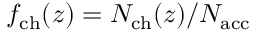<formula> <loc_0><loc_0><loc_500><loc_500>f _ { c h } ( z ) = N _ { c h } ( z ) / { N _ { a c c } }</formula> 